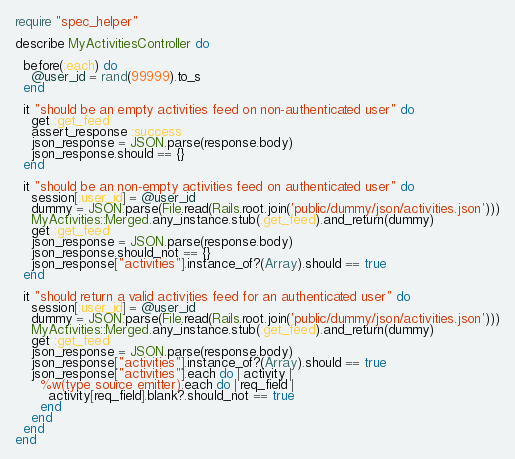<code> <loc_0><loc_0><loc_500><loc_500><_Ruby_>require "spec_helper"

describe MyActivitiesController do

  before(:each) do
    @user_id = rand(99999).to_s
  end

  it "should be an empty activities feed on non-authenticated user" do
    get :get_feed
    assert_response :success
    json_response = JSON.parse(response.body)
    json_response.should == {}
  end

  it "should be an non-empty activities feed on authenticated user" do
    session[:user_id] = @user_id
    dummy = JSON.parse(File.read(Rails.root.join('public/dummy/json/activities.json')))
    MyActivities::Merged.any_instance.stub(:get_feed).and_return(dummy)
    get :get_feed
    json_response = JSON.parse(response.body)
    json_response.should_not == {}
    json_response["activities"].instance_of?(Array).should == true
  end

  it "should return a valid activities feed for an authenticated user" do
    session[:user_id] = @user_id
    dummy = JSON.parse(File.read(Rails.root.join('public/dummy/json/activities.json')))
    MyActivities::Merged.any_instance.stub(:get_feed).and_return(dummy)
    get :get_feed
    json_response = JSON.parse(response.body)
    json_response["activities"].instance_of?(Array).should == true
    json_response["activities"].each do | activity |
      %w(type source emitter).each do | req_field |
        activity[req_field].blank?.should_not == true
      end
    end
  end
end
</code> 